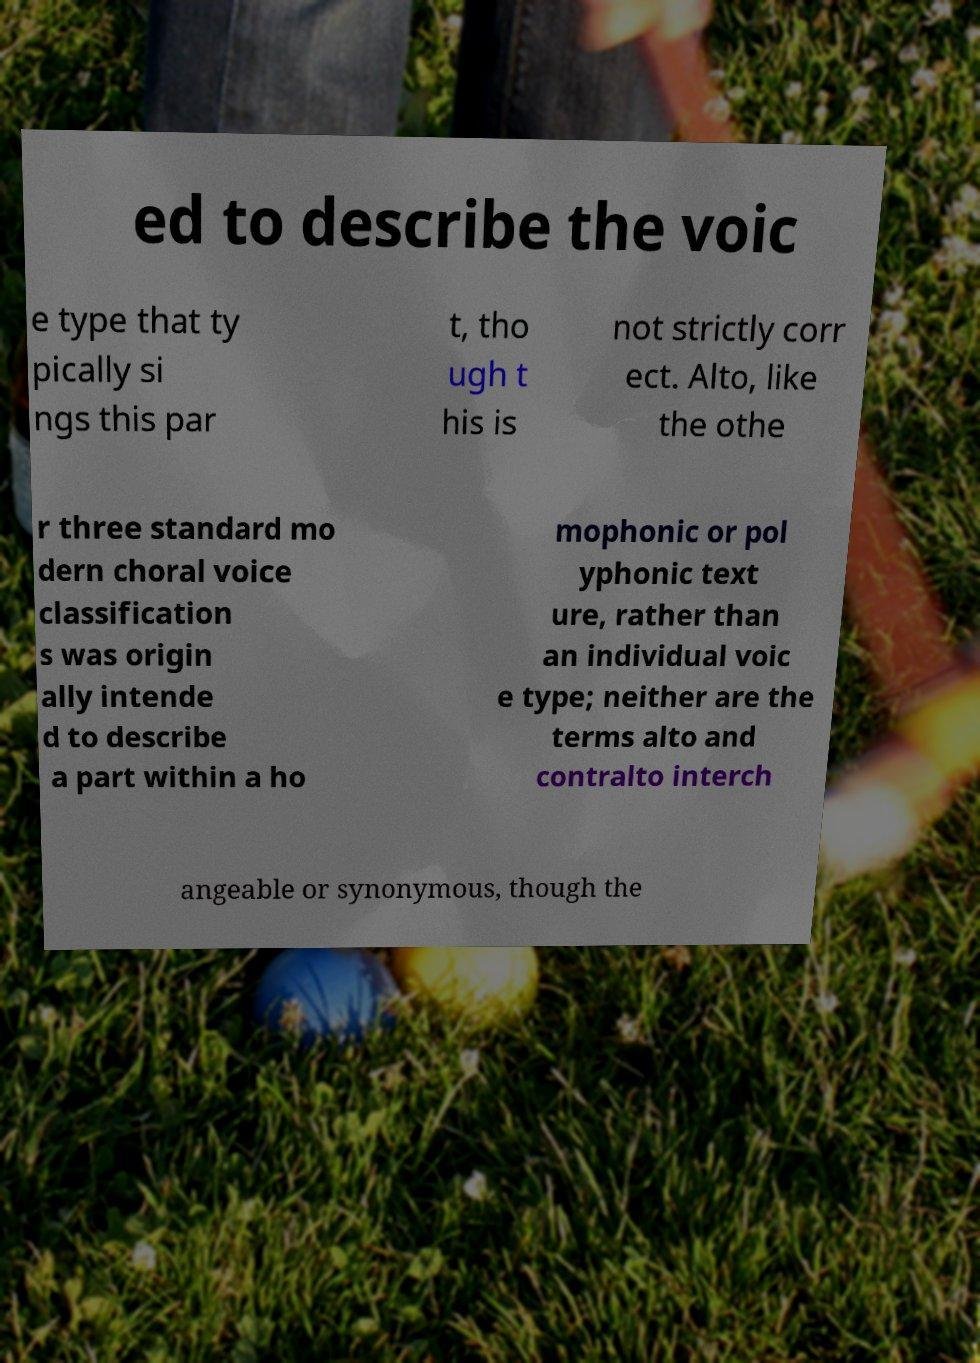Could you assist in decoding the text presented in this image and type it out clearly? ed to describe the voic e type that ty pically si ngs this par t, tho ugh t his is not strictly corr ect. Alto, like the othe r three standard mo dern choral voice classification s was origin ally intende d to describe a part within a ho mophonic or pol yphonic text ure, rather than an individual voic e type; neither are the terms alto and contralto interch angeable or synonymous, though the 